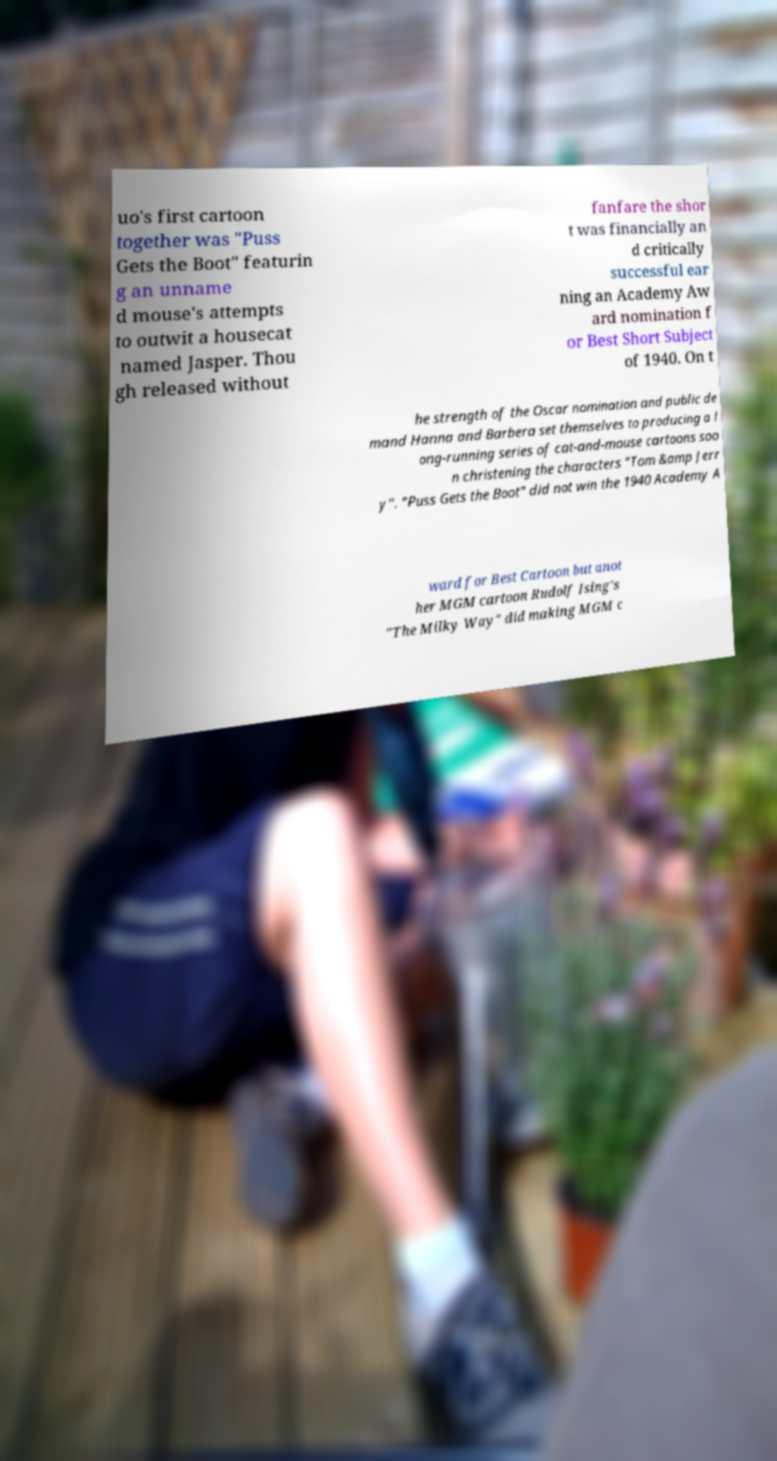Can you read and provide the text displayed in the image?This photo seems to have some interesting text. Can you extract and type it out for me? uo's first cartoon together was "Puss Gets the Boot" featurin g an unname d mouse's attempts to outwit a housecat named Jasper. Thou gh released without fanfare the shor t was financially an d critically successful ear ning an Academy Aw ard nomination f or Best Short Subject of 1940. On t he strength of the Oscar nomination and public de mand Hanna and Barbera set themselves to producing a l ong-running series of cat-and-mouse cartoons soo n christening the characters "Tom &amp Jerr y". "Puss Gets the Boot" did not win the 1940 Academy A ward for Best Cartoon but anot her MGM cartoon Rudolf Ising's "The Milky Way" did making MGM c 